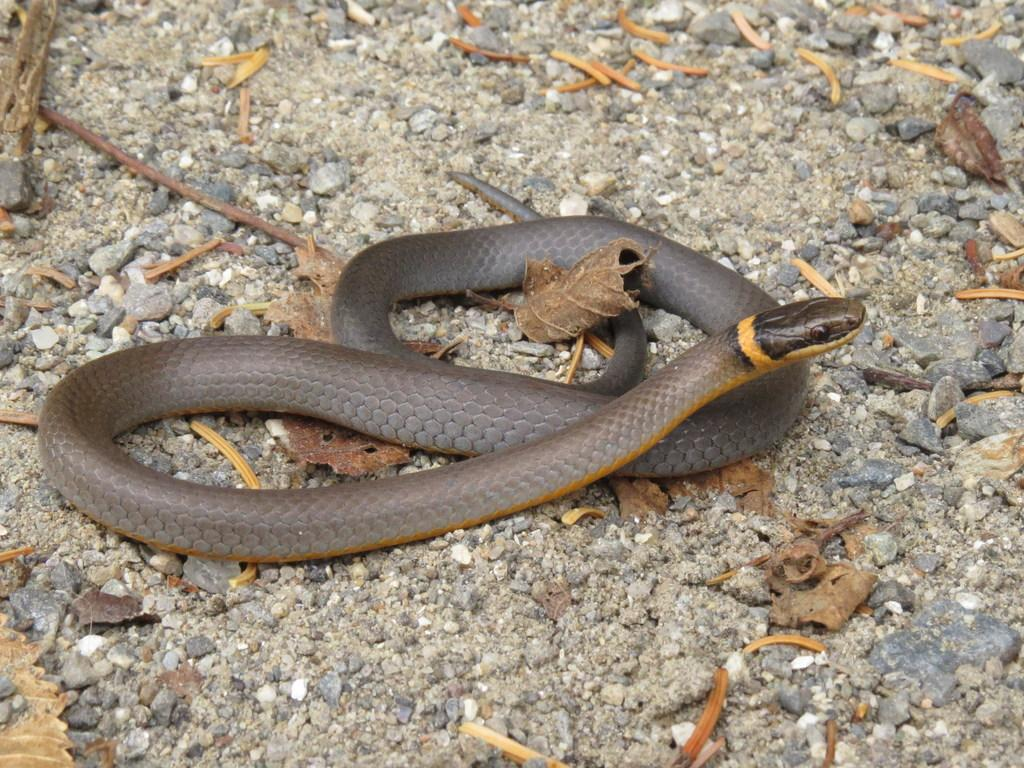What type of animal can be seen in the image? There is a snake in the image. What can be found on the ground in the image? Dry leaves are present on the land in the image. What is the primary setting of the image? The land is visible in the image. How does the snake kick the rock in the image? There is no rock present in the image, and snakes do not have the ability to kick. 